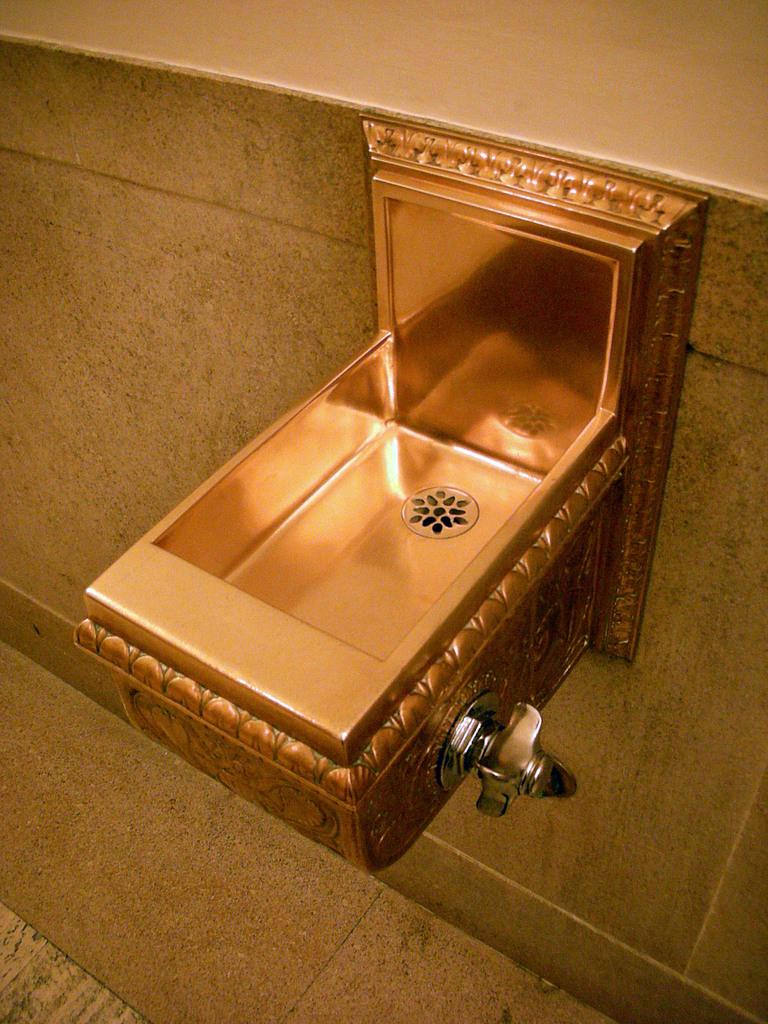Where was the image taken? The image is taken in a washroom. What can be seen in the front of the image? There is a sink in the front of the image. How is the sink attached to the wall? The sink is fixed to the wall. What part of the washroom is visible at the bottom of the image? There is a floor visible at the bottom of the image. What type of stick is the writer using to write on the wall in the image? There is no writer or stick present in the image, and no writing on the wall is visible. 